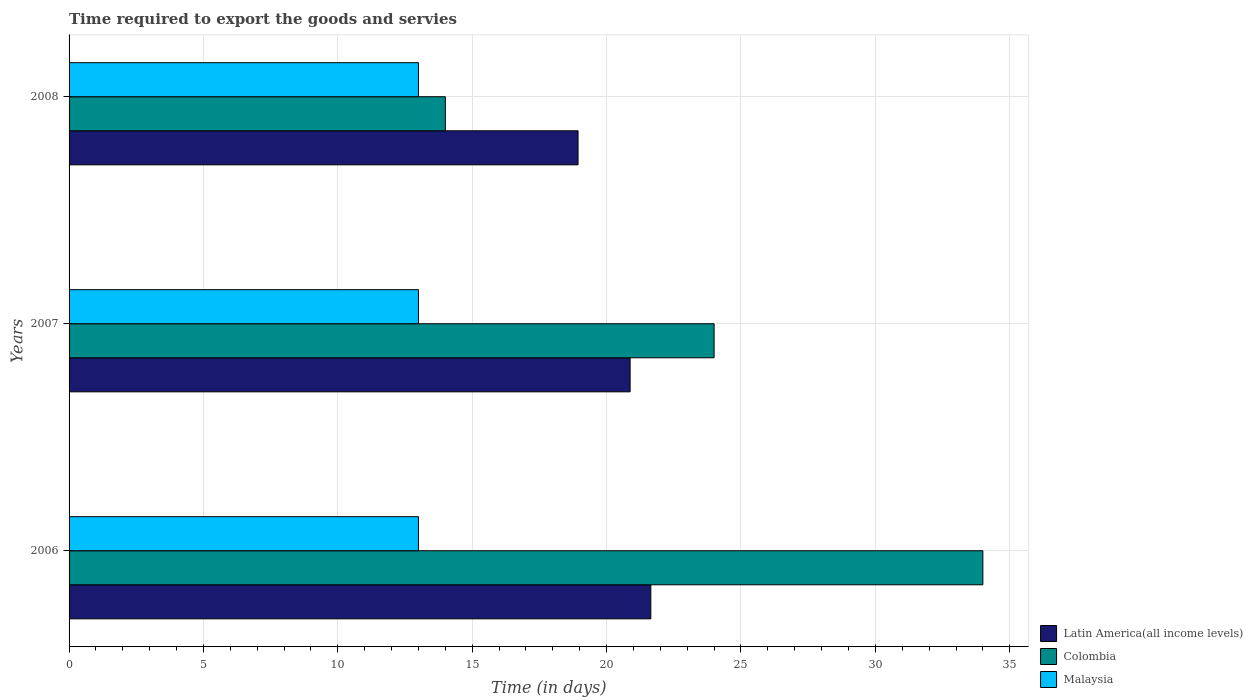Are the number of bars per tick equal to the number of legend labels?
Make the answer very short. Yes. Are the number of bars on each tick of the Y-axis equal?
Provide a succinct answer. Yes. What is the label of the 3rd group of bars from the top?
Your answer should be very brief. 2006. In how many cases, is the number of bars for a given year not equal to the number of legend labels?
Provide a succinct answer. 0. What is the number of days required to export the goods and services in Latin America(all income levels) in 2008?
Provide a short and direct response. 18.94. Across all years, what is the maximum number of days required to export the goods and services in Colombia?
Keep it short and to the point. 34. Across all years, what is the minimum number of days required to export the goods and services in Latin America(all income levels)?
Give a very brief answer. 18.94. In which year was the number of days required to export the goods and services in Colombia maximum?
Your answer should be very brief. 2006. What is the total number of days required to export the goods and services in Colombia in the graph?
Your answer should be compact. 72. What is the difference between the number of days required to export the goods and services in Latin America(all income levels) in 2007 and that in 2008?
Provide a succinct answer. 1.94. What is the difference between the number of days required to export the goods and services in Malaysia in 2006 and the number of days required to export the goods and services in Latin America(all income levels) in 2008?
Provide a succinct answer. -5.94. In the year 2006, what is the difference between the number of days required to export the goods and services in Latin America(all income levels) and number of days required to export the goods and services in Colombia?
Offer a very short reply. -12.35. What is the ratio of the number of days required to export the goods and services in Malaysia in 2007 to that in 2008?
Your answer should be compact. 1. Is the difference between the number of days required to export the goods and services in Latin America(all income levels) in 2006 and 2008 greater than the difference between the number of days required to export the goods and services in Colombia in 2006 and 2008?
Provide a succinct answer. No. What is the difference between the highest and the second highest number of days required to export the goods and services in Malaysia?
Your response must be concise. 0. What is the difference between the highest and the lowest number of days required to export the goods and services in Latin America(all income levels)?
Your response must be concise. 2.71. In how many years, is the number of days required to export the goods and services in Malaysia greater than the average number of days required to export the goods and services in Malaysia taken over all years?
Your answer should be compact. 0. What does the 2nd bar from the top in 2006 represents?
Your answer should be very brief. Colombia. What does the 3rd bar from the bottom in 2007 represents?
Offer a very short reply. Malaysia. Is it the case that in every year, the sum of the number of days required to export the goods and services in Latin America(all income levels) and number of days required to export the goods and services in Colombia is greater than the number of days required to export the goods and services in Malaysia?
Offer a terse response. Yes. How many bars are there?
Keep it short and to the point. 9. Are all the bars in the graph horizontal?
Your answer should be very brief. Yes. How many years are there in the graph?
Your answer should be very brief. 3. Are the values on the major ticks of X-axis written in scientific E-notation?
Offer a very short reply. No. Does the graph contain any zero values?
Your answer should be compact. No. Where does the legend appear in the graph?
Your response must be concise. Bottom right. What is the title of the graph?
Provide a succinct answer. Time required to export the goods and servies. Does "Macao" appear as one of the legend labels in the graph?
Your answer should be very brief. No. What is the label or title of the X-axis?
Ensure brevity in your answer.  Time (in days). What is the Time (in days) in Latin America(all income levels) in 2006?
Give a very brief answer. 21.65. What is the Time (in days) in Colombia in 2006?
Your response must be concise. 34. What is the Time (in days) of Latin America(all income levels) in 2007?
Your answer should be compact. 20.88. What is the Time (in days) in Colombia in 2007?
Offer a very short reply. 24. What is the Time (in days) of Malaysia in 2007?
Give a very brief answer. 13. What is the Time (in days) in Latin America(all income levels) in 2008?
Your answer should be compact. 18.94. Across all years, what is the maximum Time (in days) of Latin America(all income levels)?
Your answer should be very brief. 21.65. Across all years, what is the minimum Time (in days) of Latin America(all income levels)?
Make the answer very short. 18.94. Across all years, what is the minimum Time (in days) of Colombia?
Offer a very short reply. 14. What is the total Time (in days) in Latin America(all income levels) in the graph?
Provide a short and direct response. 61.46. What is the total Time (in days) in Malaysia in the graph?
Make the answer very short. 39. What is the difference between the Time (in days) of Latin America(all income levels) in 2006 and that in 2007?
Keep it short and to the point. 0.77. What is the difference between the Time (in days) of Colombia in 2006 and that in 2007?
Your answer should be compact. 10. What is the difference between the Time (in days) in Malaysia in 2006 and that in 2007?
Your response must be concise. 0. What is the difference between the Time (in days) of Latin America(all income levels) in 2006 and that in 2008?
Keep it short and to the point. 2.71. What is the difference between the Time (in days) in Colombia in 2006 and that in 2008?
Your answer should be compact. 20. What is the difference between the Time (in days) in Latin America(all income levels) in 2007 and that in 2008?
Provide a succinct answer. 1.94. What is the difference between the Time (in days) of Malaysia in 2007 and that in 2008?
Offer a terse response. 0. What is the difference between the Time (in days) in Latin America(all income levels) in 2006 and the Time (in days) in Colombia in 2007?
Ensure brevity in your answer.  -2.35. What is the difference between the Time (in days) of Latin America(all income levels) in 2006 and the Time (in days) of Malaysia in 2007?
Provide a short and direct response. 8.65. What is the difference between the Time (in days) of Latin America(all income levels) in 2006 and the Time (in days) of Colombia in 2008?
Offer a very short reply. 7.65. What is the difference between the Time (in days) in Latin America(all income levels) in 2006 and the Time (in days) in Malaysia in 2008?
Keep it short and to the point. 8.65. What is the difference between the Time (in days) in Latin America(all income levels) in 2007 and the Time (in days) in Colombia in 2008?
Offer a very short reply. 6.88. What is the difference between the Time (in days) of Latin America(all income levels) in 2007 and the Time (in days) of Malaysia in 2008?
Provide a short and direct response. 7.88. What is the average Time (in days) in Latin America(all income levels) per year?
Keep it short and to the point. 20.49. In the year 2006, what is the difference between the Time (in days) of Latin America(all income levels) and Time (in days) of Colombia?
Give a very brief answer. -12.35. In the year 2006, what is the difference between the Time (in days) in Latin America(all income levels) and Time (in days) in Malaysia?
Offer a very short reply. 8.65. In the year 2007, what is the difference between the Time (in days) of Latin America(all income levels) and Time (in days) of Colombia?
Provide a succinct answer. -3.12. In the year 2007, what is the difference between the Time (in days) in Latin America(all income levels) and Time (in days) in Malaysia?
Provide a short and direct response. 7.88. In the year 2008, what is the difference between the Time (in days) in Latin America(all income levels) and Time (in days) in Colombia?
Give a very brief answer. 4.94. In the year 2008, what is the difference between the Time (in days) in Latin America(all income levels) and Time (in days) in Malaysia?
Make the answer very short. 5.94. What is the ratio of the Time (in days) of Latin America(all income levels) in 2006 to that in 2007?
Provide a succinct answer. 1.04. What is the ratio of the Time (in days) in Colombia in 2006 to that in 2007?
Ensure brevity in your answer.  1.42. What is the ratio of the Time (in days) of Malaysia in 2006 to that in 2007?
Give a very brief answer. 1. What is the ratio of the Time (in days) in Latin America(all income levels) in 2006 to that in 2008?
Give a very brief answer. 1.14. What is the ratio of the Time (in days) in Colombia in 2006 to that in 2008?
Provide a short and direct response. 2.43. What is the ratio of the Time (in days) of Malaysia in 2006 to that in 2008?
Your response must be concise. 1. What is the ratio of the Time (in days) in Latin America(all income levels) in 2007 to that in 2008?
Keep it short and to the point. 1.1. What is the ratio of the Time (in days) of Colombia in 2007 to that in 2008?
Your answer should be very brief. 1.71. What is the ratio of the Time (in days) of Malaysia in 2007 to that in 2008?
Offer a terse response. 1. What is the difference between the highest and the second highest Time (in days) of Latin America(all income levels)?
Ensure brevity in your answer.  0.77. What is the difference between the highest and the second highest Time (in days) of Colombia?
Give a very brief answer. 10. What is the difference between the highest and the second highest Time (in days) of Malaysia?
Give a very brief answer. 0. What is the difference between the highest and the lowest Time (in days) in Latin America(all income levels)?
Make the answer very short. 2.71. What is the difference between the highest and the lowest Time (in days) in Colombia?
Keep it short and to the point. 20. 